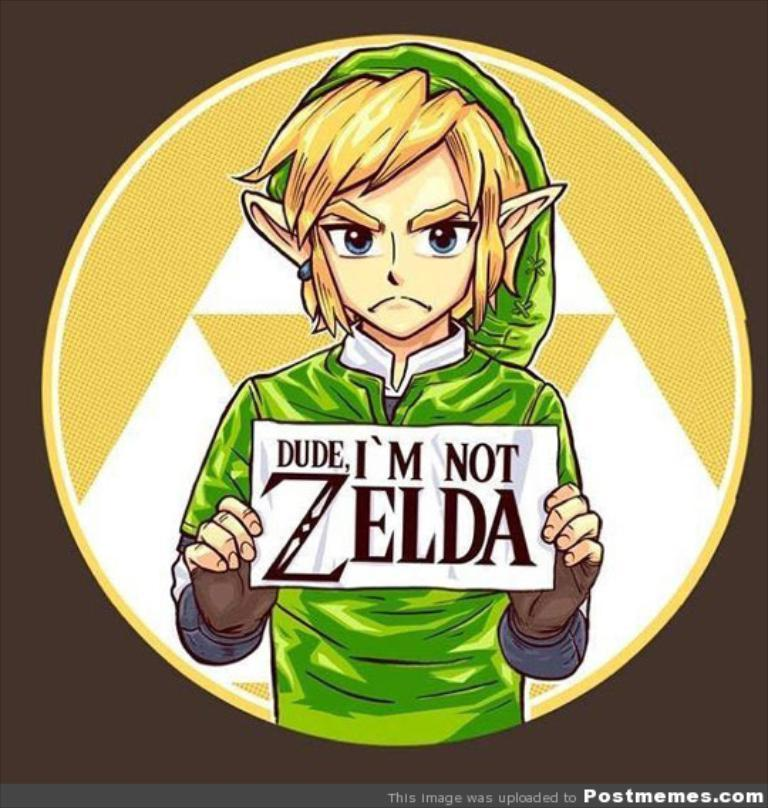<image>
Create a compact narrative representing the image presented. Link holds a sign that reads Dude, I'm not Zelda 